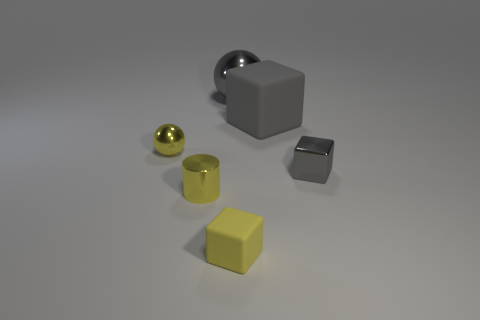Add 4 tiny yellow matte things. How many objects exist? 10 Subtract all spheres. How many objects are left? 4 Subtract 0 cyan cylinders. How many objects are left? 6 Subtract all tiny balls. Subtract all big green matte cylinders. How many objects are left? 5 Add 3 large gray objects. How many large gray objects are left? 5 Add 2 big spheres. How many big spheres exist? 3 